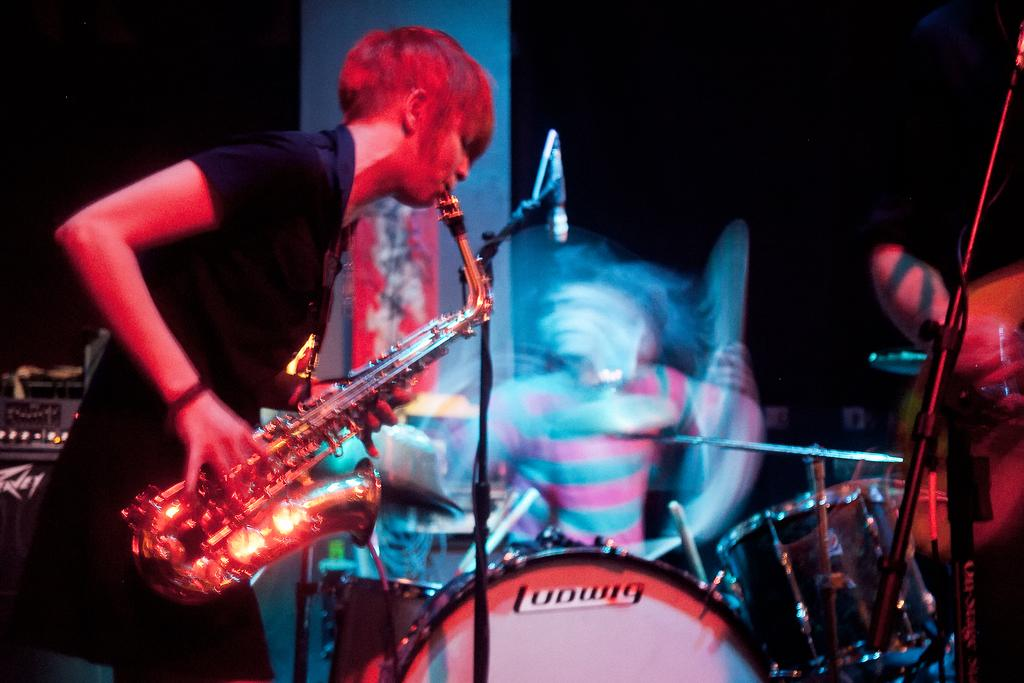What is the main subject of the image? There is a person standing in the image. What is the person holding in the image? The person is holding a musical instrument. Are there any other musical instruments visible in the image? Yes, there are music drums visible in the image. What type of range can be seen in the image? There is no range present in the image; it features a person holding a musical instrument and music drums. What is being smashed in the image? There is no object being smashed in the image. 